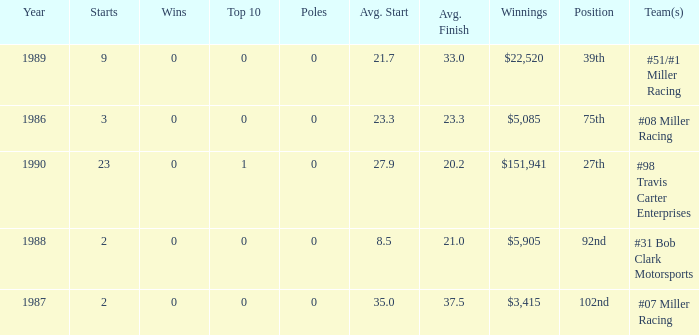What racing team/s had the 92nd position? #31 Bob Clark Motorsports. 